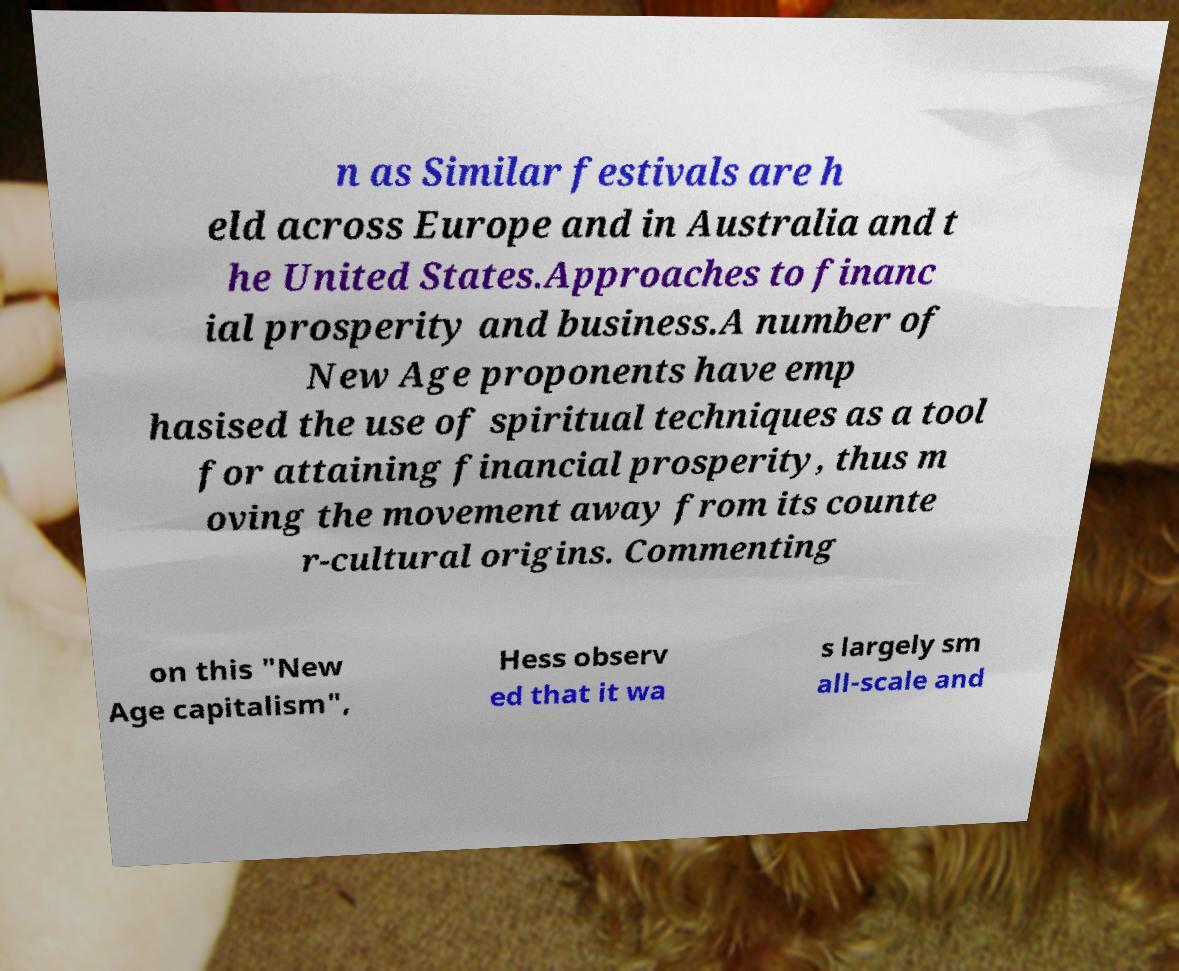Please read and relay the text visible in this image. What does it say? n as Similar festivals are h eld across Europe and in Australia and t he United States.Approaches to financ ial prosperity and business.A number of New Age proponents have emp hasised the use of spiritual techniques as a tool for attaining financial prosperity, thus m oving the movement away from its counte r-cultural origins. Commenting on this "New Age capitalism", Hess observ ed that it wa s largely sm all-scale and 